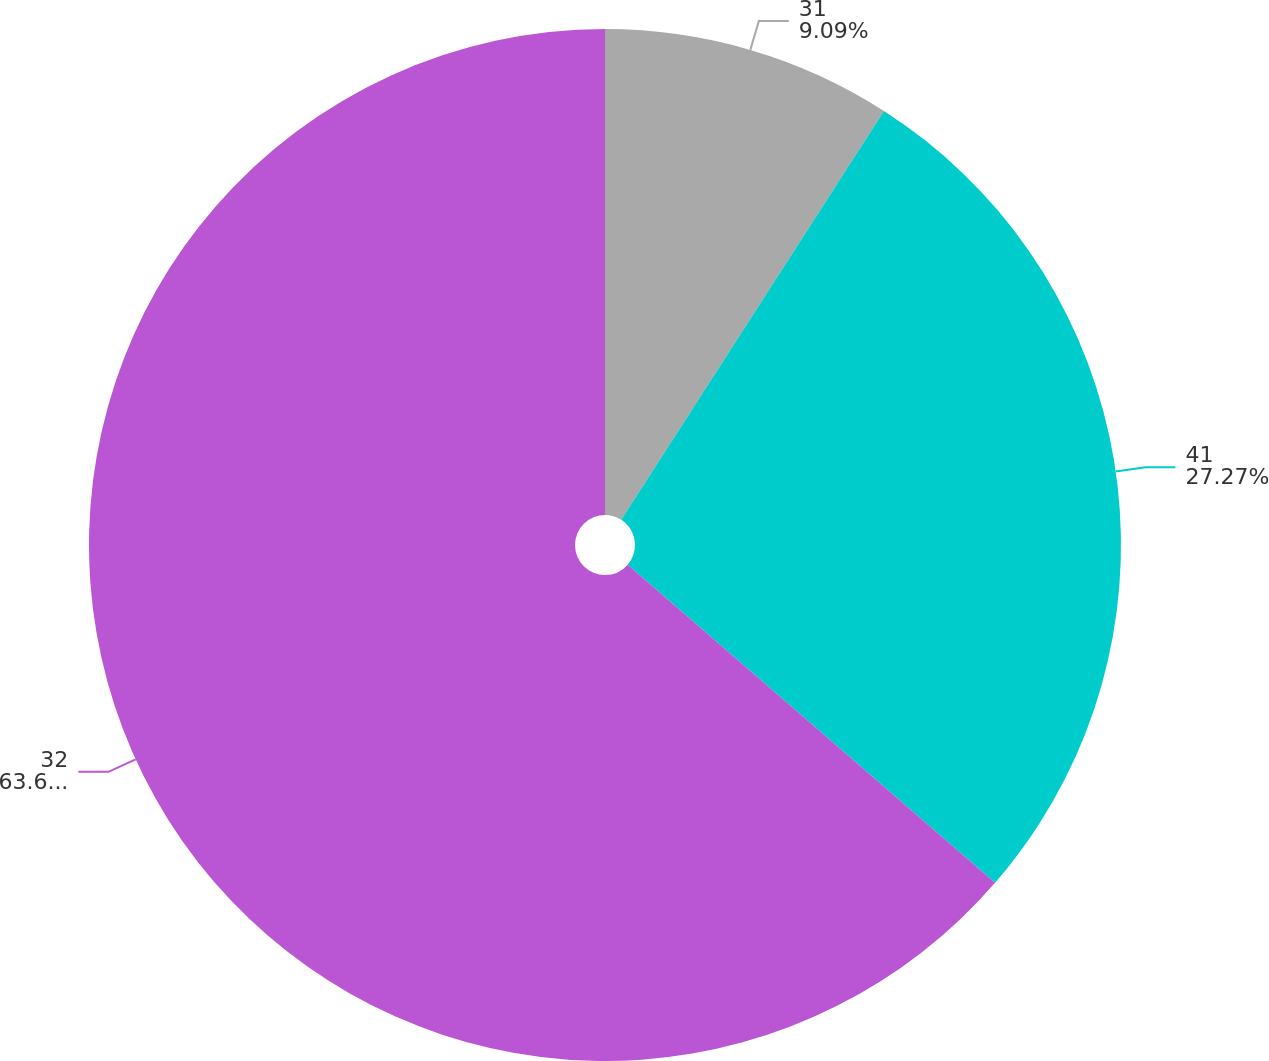<chart> <loc_0><loc_0><loc_500><loc_500><pie_chart><fcel>31<fcel>41<fcel>32<nl><fcel>9.09%<fcel>27.27%<fcel>63.64%<nl></chart> 